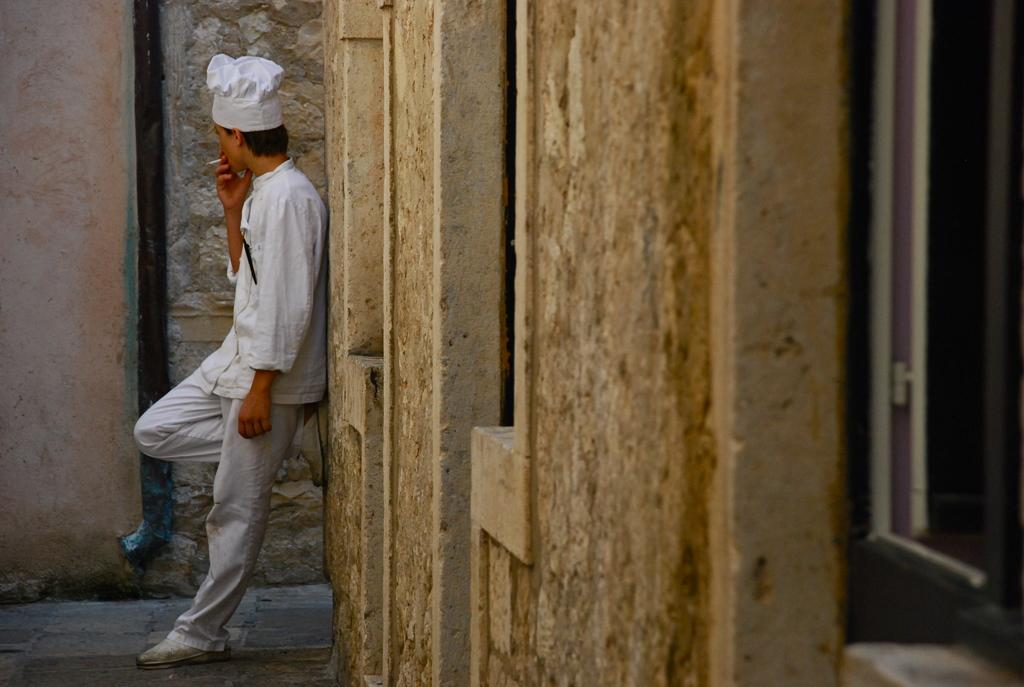What is the person in the image doing? The person is standing and smoking in the image. Can you describe the person's attire? The person is wearing a cap. What type of structures are visible in the image? There are walls visible in the image. What architectural feature can be seen in the image? There is a window in the image. How many feathers can be seen on the person's clothing in the image? There are no feathers visible on the person's clothing in the image. What type of shop is present in the image? There is no shop present in the image. How many cats are visible in the image? There are no cats visible in the image. 